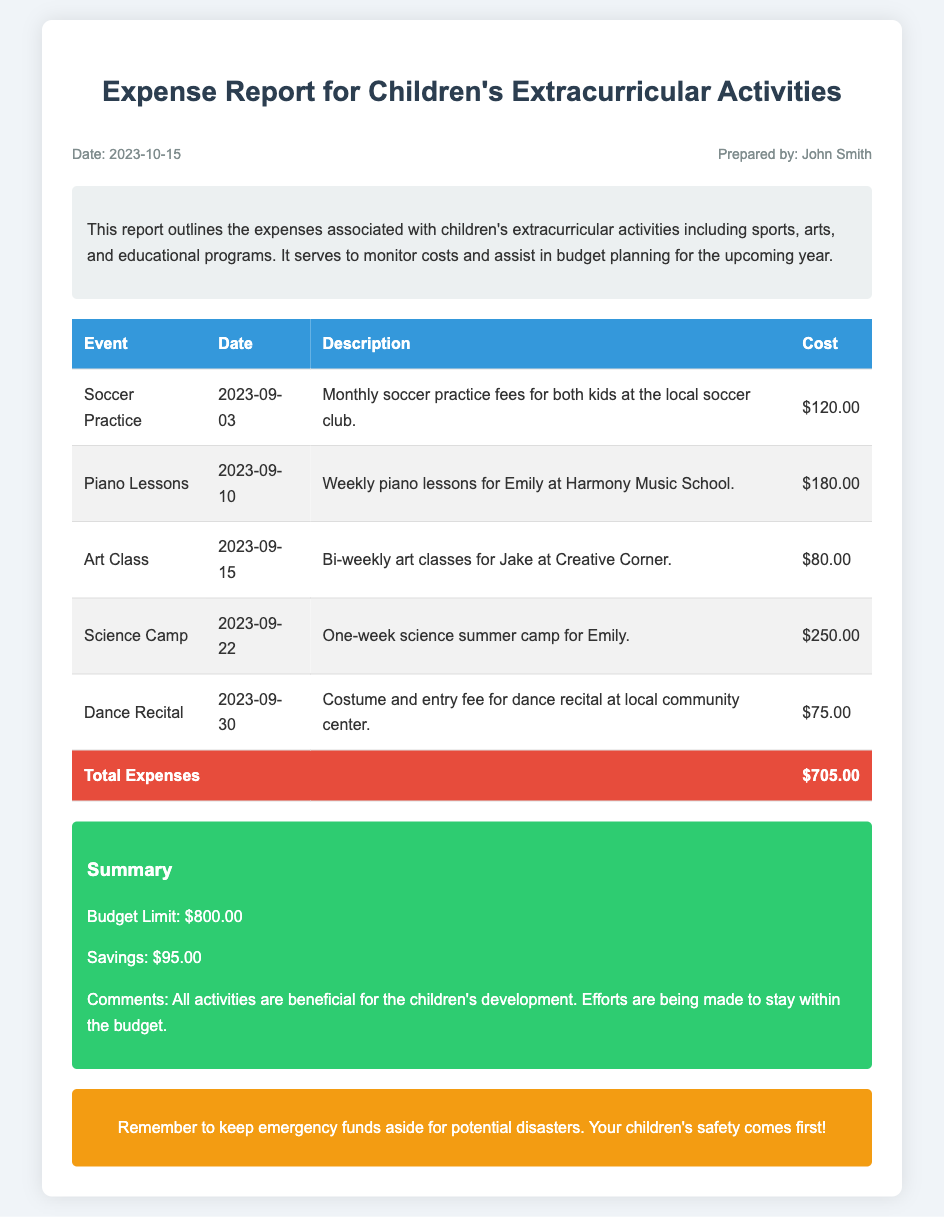What is the total amount spent on children's extracurricular activities? The total amount is located in the summary and is the total of all listed expenses, which is $705.00.
Answer: $705.00 What event has the highest cost? The highest cost is found by comparing the costs of each event, which is for Science Camp at $250.00.
Answer: Science Camp How many piano lessons did Emily have? Piano lessons are mentioned as weekly lessons; therefore, if we assume 4 weeks in September, she had 4 lessons.
Answer: 4 What is the budget limit? The budget limit is specified in the summary section, which states it is $800.00.
Answer: $800.00 What was the cost of the Dance Recital? The cost of the Dance Recital can be found in the table, which lists it as $75.00.
Answer: $75.00 What is the savings amount listed in the report? The savings amount is found in the summary section, which indicates it is $95.00.
Answer: $95.00 Which child attends the bi-weekly art classes? The document specifies that Jake attends the bi-weekly art classes.
Answer: Jake When did the Soccer Practice occur? The date of the Soccer Practice is listed in the table as 2023-09-03.
Answer: 2023-09-03 Why is it important to keep emergency funds aside? The document includes a reminder in the alert section indicating that children's safety is paramount.
Answer: Safety 